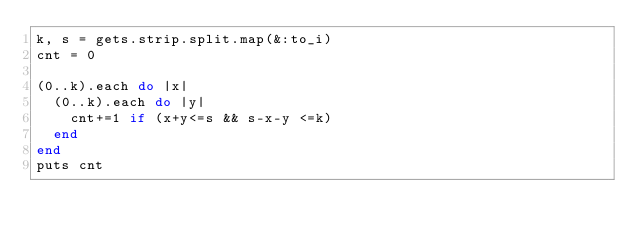<code> <loc_0><loc_0><loc_500><loc_500><_Ruby_>k, s = gets.strip.split.map(&:to_i)
cnt = 0

(0..k).each do |x|
  (0..k).each do |y|
    cnt+=1 if (x+y<=s && s-x-y <=k)
  end
end
puts cnt</code> 